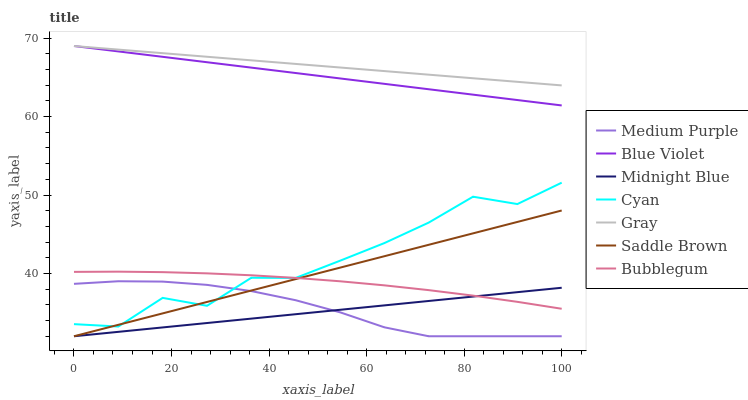Does Midnight Blue have the minimum area under the curve?
Answer yes or no. Yes. Does Gray have the maximum area under the curve?
Answer yes or no. Yes. Does Bubblegum have the minimum area under the curve?
Answer yes or no. No. Does Bubblegum have the maximum area under the curve?
Answer yes or no. No. Is Midnight Blue the smoothest?
Answer yes or no. Yes. Is Cyan the roughest?
Answer yes or no. Yes. Is Bubblegum the smoothest?
Answer yes or no. No. Is Bubblegum the roughest?
Answer yes or no. No. Does Midnight Blue have the lowest value?
Answer yes or no. Yes. Does Bubblegum have the lowest value?
Answer yes or no. No. Does Blue Violet have the highest value?
Answer yes or no. Yes. Does Bubblegum have the highest value?
Answer yes or no. No. Is Bubblegum less than Gray?
Answer yes or no. Yes. Is Bubblegum greater than Medium Purple?
Answer yes or no. Yes. Does Bubblegum intersect Midnight Blue?
Answer yes or no. Yes. Is Bubblegum less than Midnight Blue?
Answer yes or no. No. Is Bubblegum greater than Midnight Blue?
Answer yes or no. No. Does Bubblegum intersect Gray?
Answer yes or no. No. 